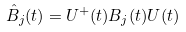Convert formula to latex. <formula><loc_0><loc_0><loc_500><loc_500>\hat { B } _ { j } ( t ) = U ^ { + } ( t ) B _ { j } ( t ) U ( t )</formula> 